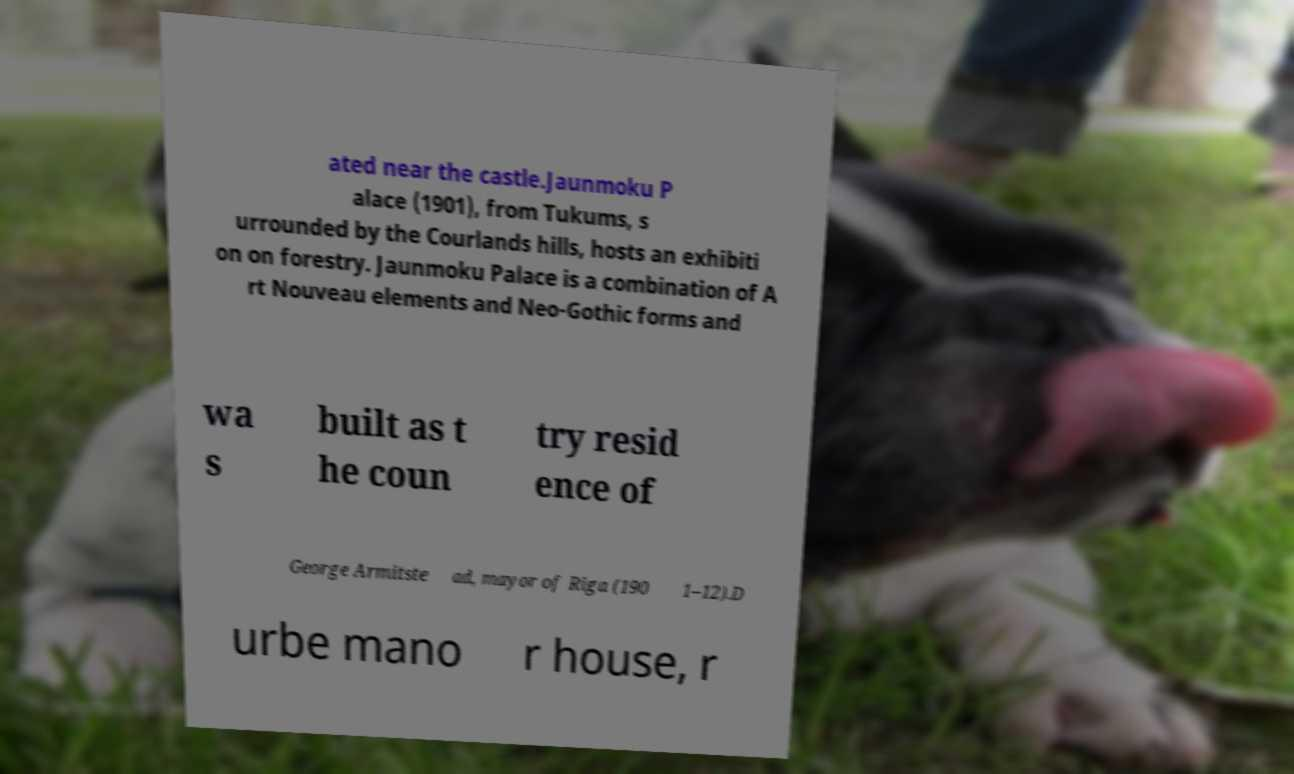Could you extract and type out the text from this image? ated near the castle.Jaunmoku P alace (1901), from Tukums, s urrounded by the Courlands hills, hosts an exhibiti on on forestry. Jaunmoku Palace is a combination of A rt Nouveau elements and Neo-Gothic forms and wa s built as t he coun try resid ence of George Armitste ad, mayor of Riga (190 1–12).D urbe mano r house, r 